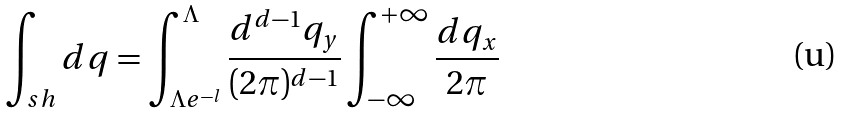Convert formula to latex. <formula><loc_0><loc_0><loc_500><loc_500>\int _ { s h } d q = \int _ { \Lambda e ^ { - l } } ^ { \Lambda } \frac { d ^ { d - 1 } q _ { y } } { ( 2 \pi ) ^ { d - 1 } } \int _ { - \infty } ^ { + \infty } \frac { d q _ { x } } { 2 \pi }</formula> 